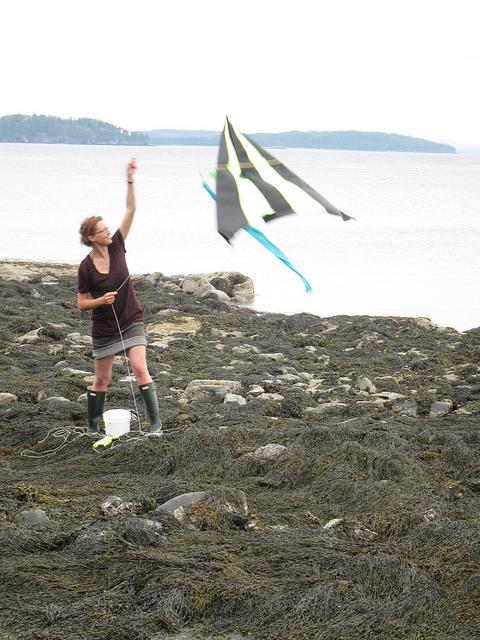What is on the woman's head?
Write a very short answer. Hair. What hobby is being shown?
Short answer required. Kite flying. What type of boots are on this woman?
Write a very short answer. Rain. How many people are in the picture?
Be succinct. 1. 